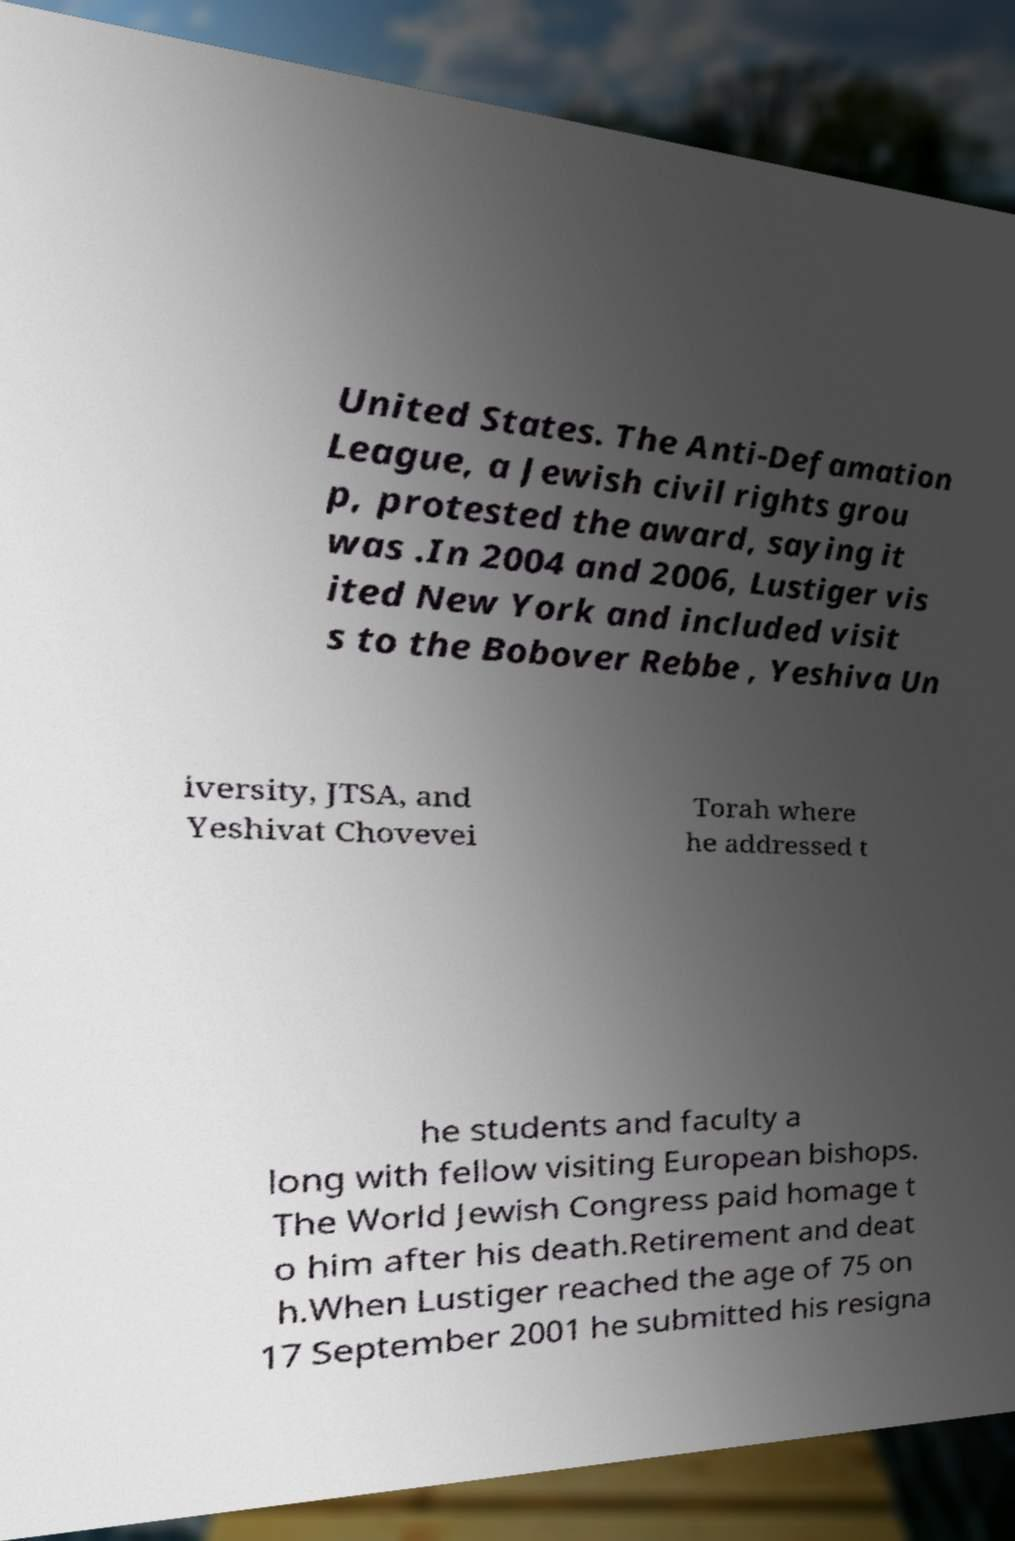Could you extract and type out the text from this image? United States. The Anti-Defamation League, a Jewish civil rights grou p, protested the award, saying it was .In 2004 and 2006, Lustiger vis ited New York and included visit s to the Bobover Rebbe , Yeshiva Un iversity, JTSA, and Yeshivat Chovevei Torah where he addressed t he students and faculty a long with fellow visiting European bishops. The World Jewish Congress paid homage t o him after his death.Retirement and deat h.When Lustiger reached the age of 75 on 17 September 2001 he submitted his resigna 